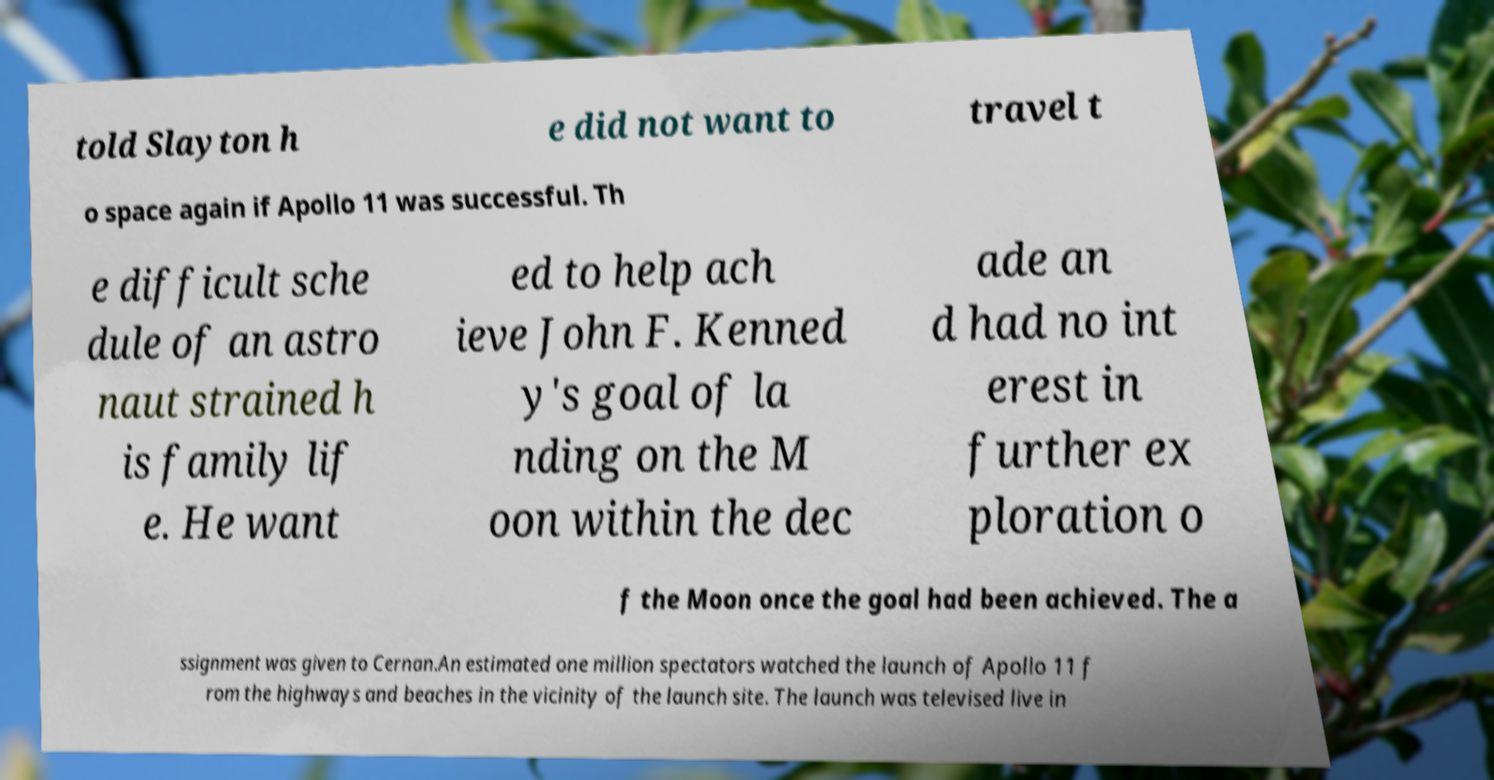Can you read and provide the text displayed in the image?This photo seems to have some interesting text. Can you extract and type it out for me? told Slayton h e did not want to travel t o space again if Apollo 11 was successful. Th e difficult sche dule of an astro naut strained h is family lif e. He want ed to help ach ieve John F. Kenned y's goal of la nding on the M oon within the dec ade an d had no int erest in further ex ploration o f the Moon once the goal had been achieved. The a ssignment was given to Cernan.An estimated one million spectators watched the launch of Apollo 11 f rom the highways and beaches in the vicinity of the launch site. The launch was televised live in 